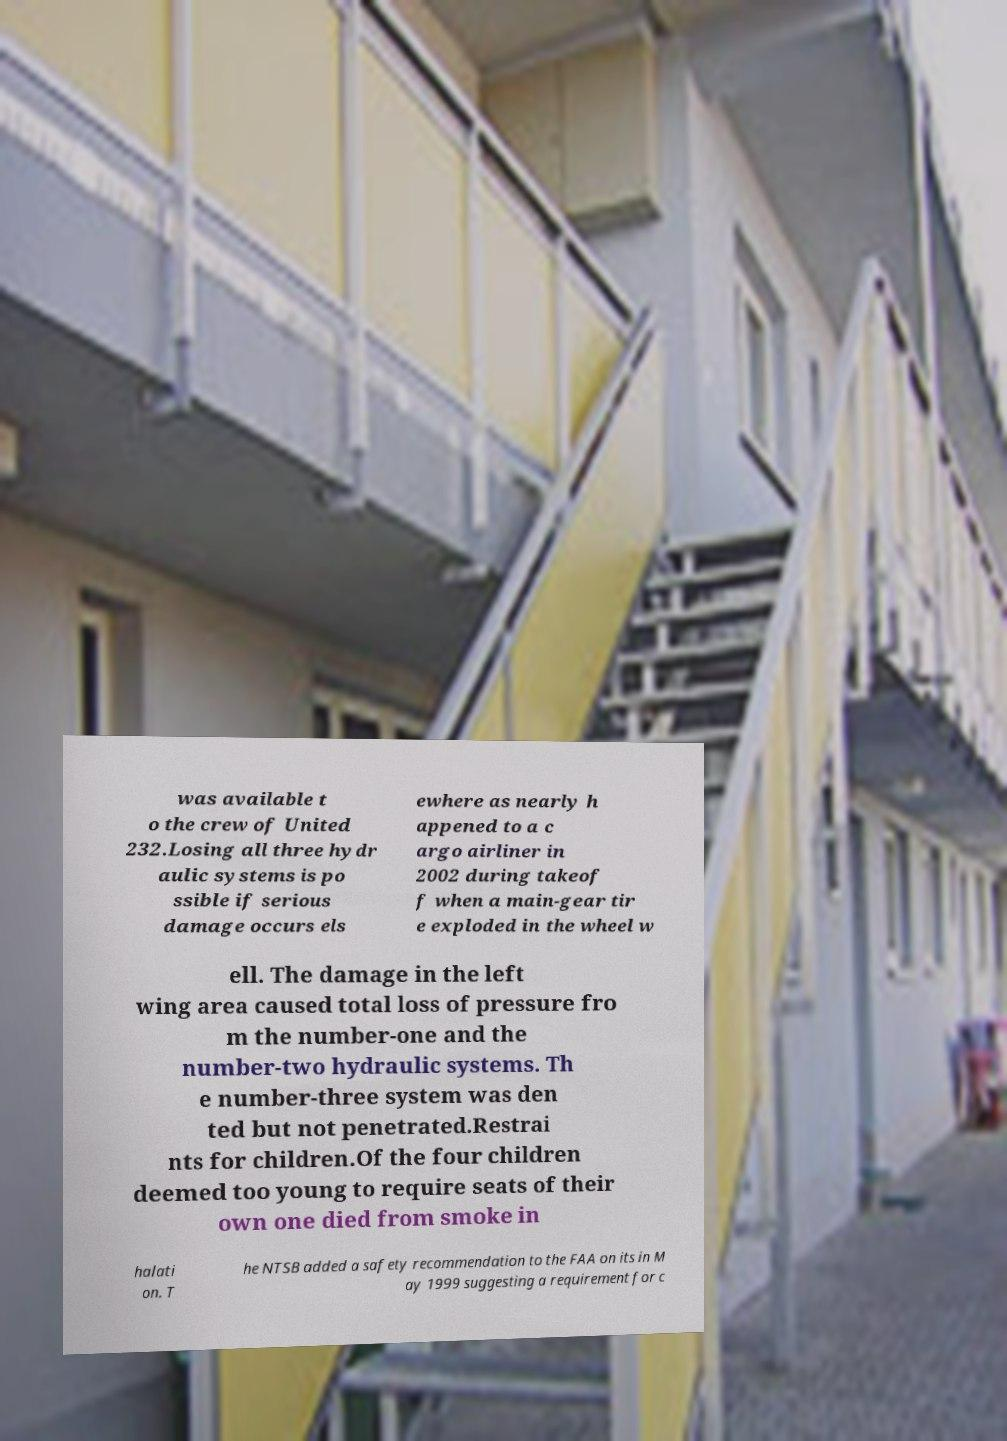Can you accurately transcribe the text from the provided image for me? was available t o the crew of United 232.Losing all three hydr aulic systems is po ssible if serious damage occurs els ewhere as nearly h appened to a c argo airliner in 2002 during takeof f when a main-gear tir e exploded in the wheel w ell. The damage in the left wing area caused total loss of pressure fro m the number-one and the number-two hydraulic systems. Th e number-three system was den ted but not penetrated.Restrai nts for children.Of the four children deemed too young to require seats of their own one died from smoke in halati on. T he NTSB added a safety recommendation to the FAA on its in M ay 1999 suggesting a requirement for c 